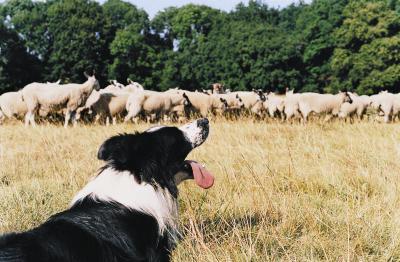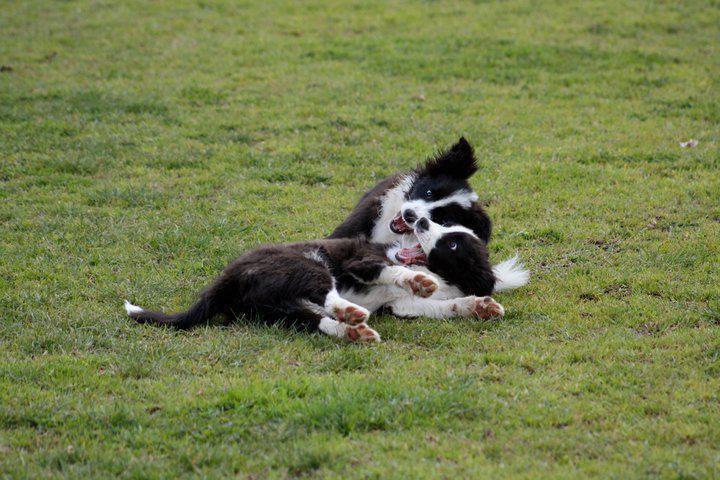The first image is the image on the left, the second image is the image on the right. Examine the images to the left and right. Is the description "One image shows a black-and-white dog herding livestock, and the other shows one puppy in bright green grass near wildflowers." accurate? Answer yes or no. No. The first image is the image on the left, the second image is the image on the right. Assess this claim about the two images: "The image on the left shows an Australian sheepdog herding 2 or 3 sheep or goats, and the one on the right shows an Australian sheepdog puppy on its own.". Correct or not? Answer yes or no. No. 